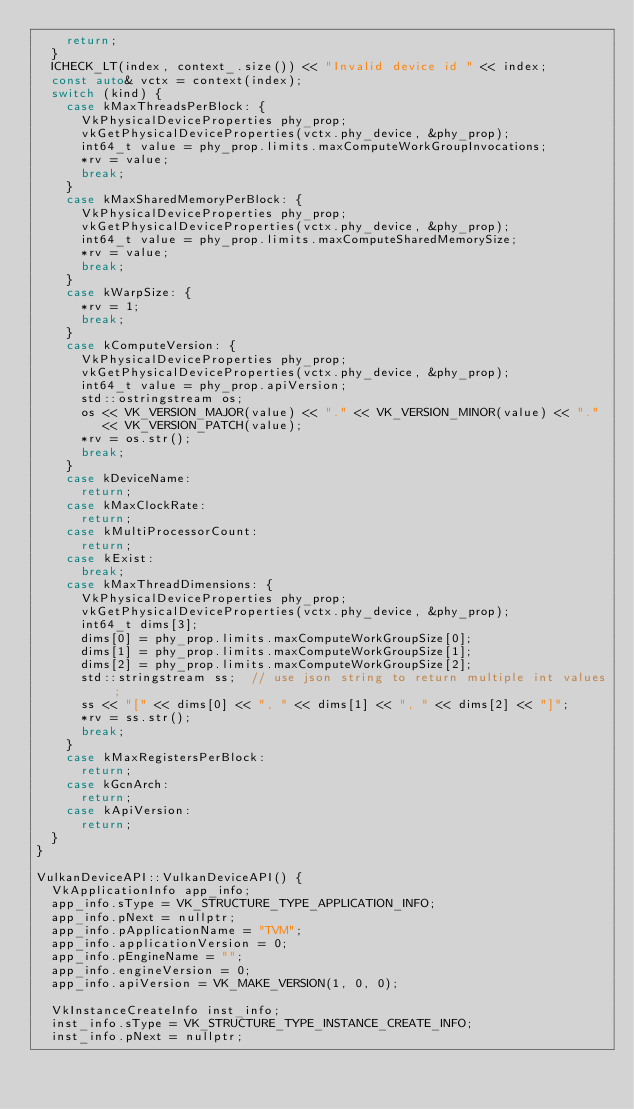<code> <loc_0><loc_0><loc_500><loc_500><_C++_>    return;
  }
  ICHECK_LT(index, context_.size()) << "Invalid device id " << index;
  const auto& vctx = context(index);
  switch (kind) {
    case kMaxThreadsPerBlock: {
      VkPhysicalDeviceProperties phy_prop;
      vkGetPhysicalDeviceProperties(vctx.phy_device, &phy_prop);
      int64_t value = phy_prop.limits.maxComputeWorkGroupInvocations;
      *rv = value;
      break;
    }
    case kMaxSharedMemoryPerBlock: {
      VkPhysicalDeviceProperties phy_prop;
      vkGetPhysicalDeviceProperties(vctx.phy_device, &phy_prop);
      int64_t value = phy_prop.limits.maxComputeSharedMemorySize;
      *rv = value;
      break;
    }
    case kWarpSize: {
      *rv = 1;
      break;
    }
    case kComputeVersion: {
      VkPhysicalDeviceProperties phy_prop;
      vkGetPhysicalDeviceProperties(vctx.phy_device, &phy_prop);
      int64_t value = phy_prop.apiVersion;
      std::ostringstream os;
      os << VK_VERSION_MAJOR(value) << "." << VK_VERSION_MINOR(value) << "."
         << VK_VERSION_PATCH(value);
      *rv = os.str();
      break;
    }
    case kDeviceName:
      return;
    case kMaxClockRate:
      return;
    case kMultiProcessorCount:
      return;
    case kExist:
      break;
    case kMaxThreadDimensions: {
      VkPhysicalDeviceProperties phy_prop;
      vkGetPhysicalDeviceProperties(vctx.phy_device, &phy_prop);
      int64_t dims[3];
      dims[0] = phy_prop.limits.maxComputeWorkGroupSize[0];
      dims[1] = phy_prop.limits.maxComputeWorkGroupSize[1];
      dims[2] = phy_prop.limits.maxComputeWorkGroupSize[2];
      std::stringstream ss;  // use json string to return multiple int values;
      ss << "[" << dims[0] << ", " << dims[1] << ", " << dims[2] << "]";
      *rv = ss.str();
      break;
    }
    case kMaxRegistersPerBlock:
      return;
    case kGcnArch:
      return;
    case kApiVersion:
      return;
  }
}

VulkanDeviceAPI::VulkanDeviceAPI() {
  VkApplicationInfo app_info;
  app_info.sType = VK_STRUCTURE_TYPE_APPLICATION_INFO;
  app_info.pNext = nullptr;
  app_info.pApplicationName = "TVM";
  app_info.applicationVersion = 0;
  app_info.pEngineName = "";
  app_info.engineVersion = 0;
  app_info.apiVersion = VK_MAKE_VERSION(1, 0, 0);

  VkInstanceCreateInfo inst_info;
  inst_info.sType = VK_STRUCTURE_TYPE_INSTANCE_CREATE_INFO;
  inst_info.pNext = nullptr;</code> 